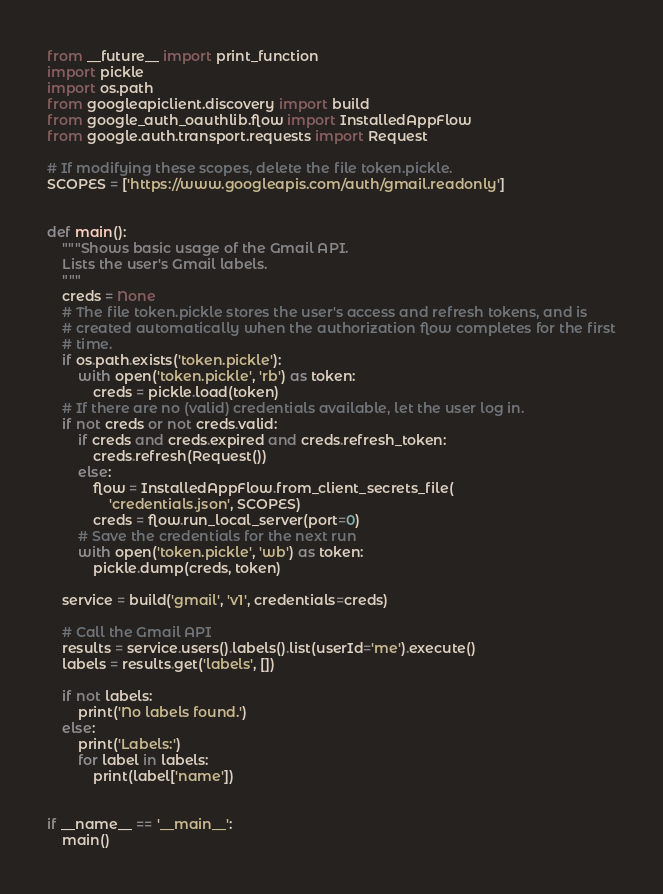Convert code to text. <code><loc_0><loc_0><loc_500><loc_500><_Python_>from __future__ import print_function
import pickle
import os.path
from googleapiclient.discovery import build
from google_auth_oauthlib.flow import InstalledAppFlow
from google.auth.transport.requests import Request

# If modifying these scopes, delete the file token.pickle.
SCOPES = ['https://www.googleapis.com/auth/gmail.readonly']


def main():
    """Shows basic usage of the Gmail API.
    Lists the user's Gmail labels.
    """
    creds = None
    # The file token.pickle stores the user's access and refresh tokens, and is
    # created automatically when the authorization flow completes for the first
    # time.
    if os.path.exists('token.pickle'):
        with open('token.pickle', 'rb') as token:
            creds = pickle.load(token)
    # If there are no (valid) credentials available, let the user log in.
    if not creds or not creds.valid:
        if creds and creds.expired and creds.refresh_token:
            creds.refresh(Request())
        else:
            flow = InstalledAppFlow.from_client_secrets_file(
                'credentials.json', SCOPES)
            creds = flow.run_local_server(port=0)
        # Save the credentials for the next run
        with open('token.pickle', 'wb') as token:
            pickle.dump(creds, token)

    service = build('gmail', 'v1', credentials=creds)

    # Call the Gmail API
    results = service.users().labels().list(userId='me').execute()
    labels = results.get('labels', [])

    if not labels:
        print('No labels found.')
    else:
        print('Labels:')
        for label in labels:
            print(label['name'])


if __name__ == '__main__':
    main()
</code> 